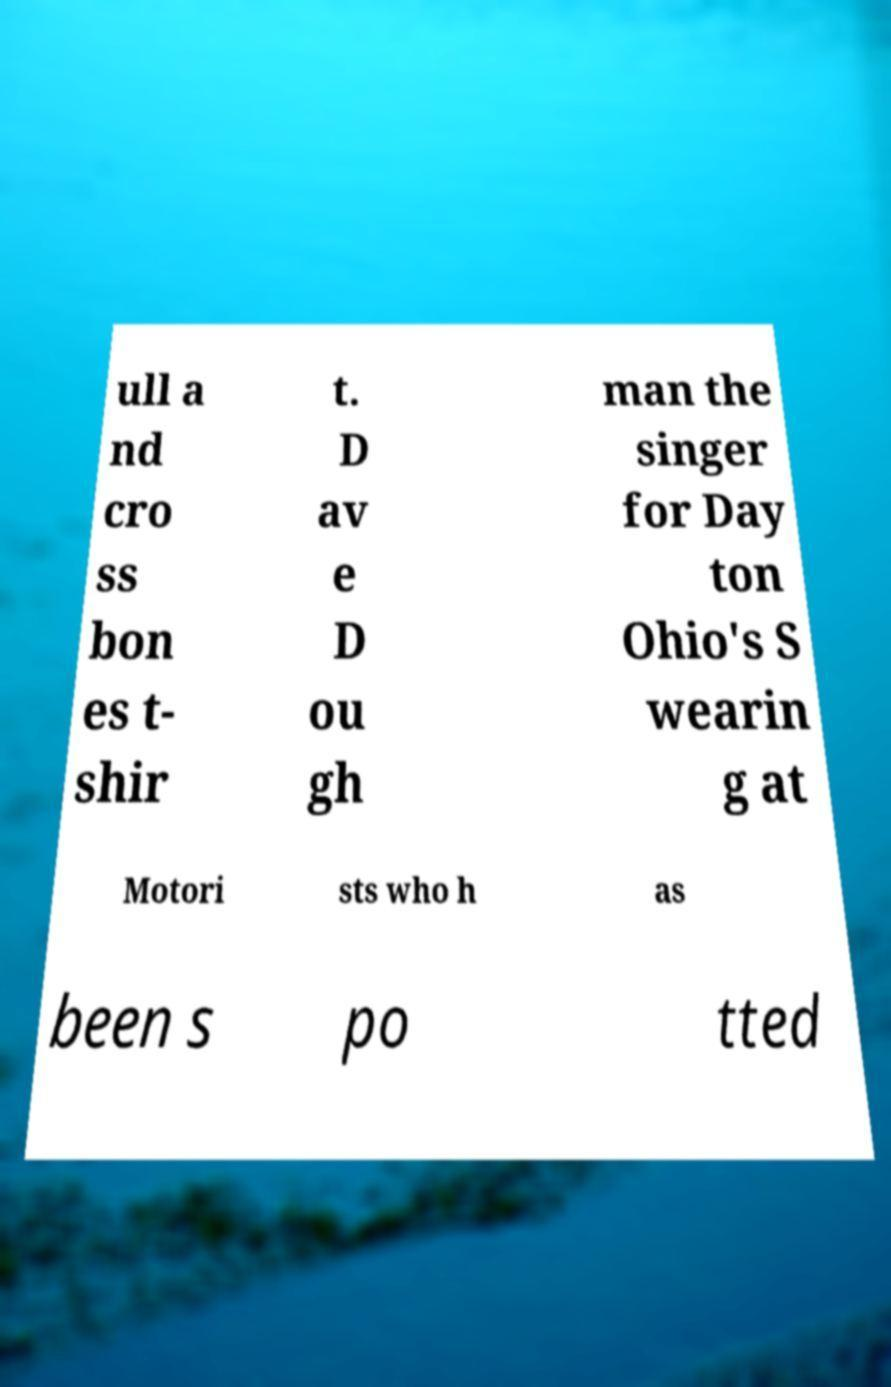What messages or text are displayed in this image? I need them in a readable, typed format. ull a nd cro ss bon es t- shir t. D av e D ou gh man the singer for Day ton Ohio's S wearin g at Motori sts who h as been s po tted 